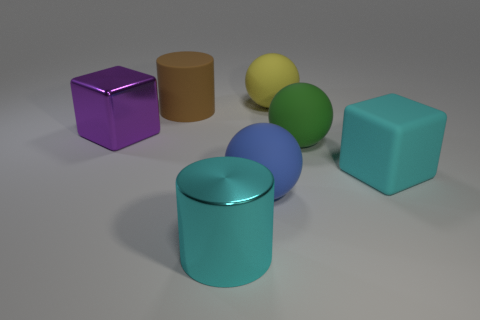Add 2 large cyan cubes. How many objects exist? 9 Subtract all blue matte balls. How many balls are left? 2 Subtract 1 spheres. How many spheres are left? 2 Subtract all spheres. How many objects are left? 4 Subtract 0 gray blocks. How many objects are left? 7 Subtract all blue balls. Subtract all cyan cylinders. How many balls are left? 2 Subtract all blue matte objects. Subtract all spheres. How many objects are left? 3 Add 5 cyan cubes. How many cyan cubes are left? 6 Add 4 big cyan rubber objects. How many big cyan rubber objects exist? 5 